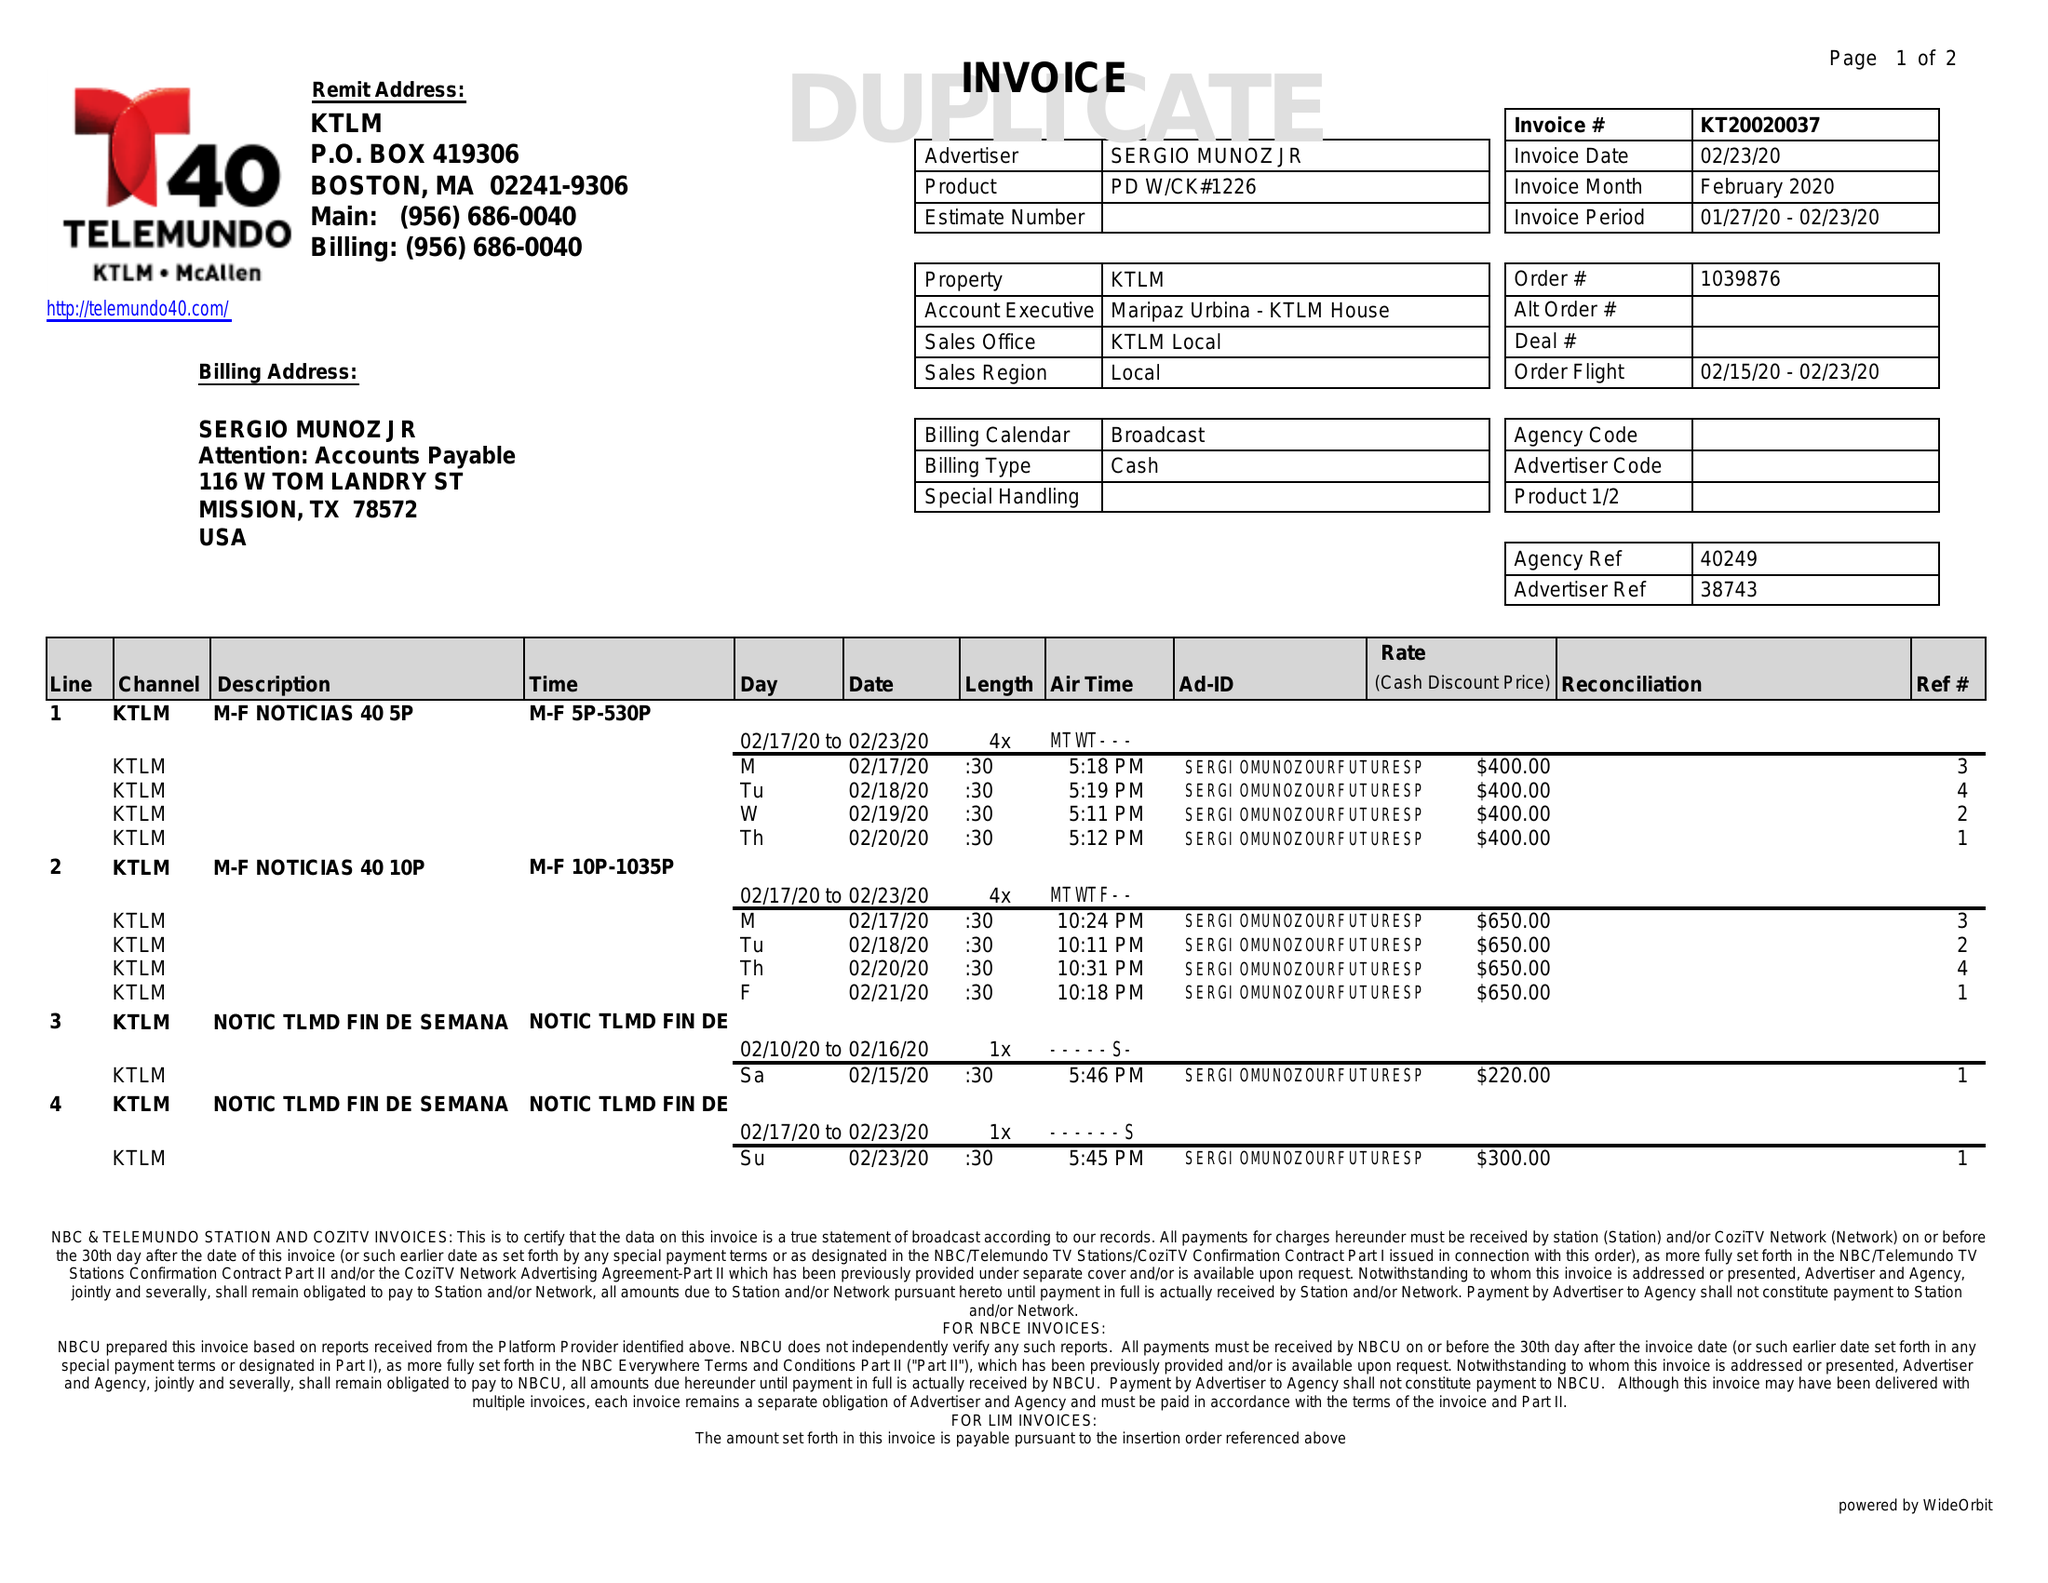What is the value for the flight_from?
Answer the question using a single word or phrase. 02/15/20 